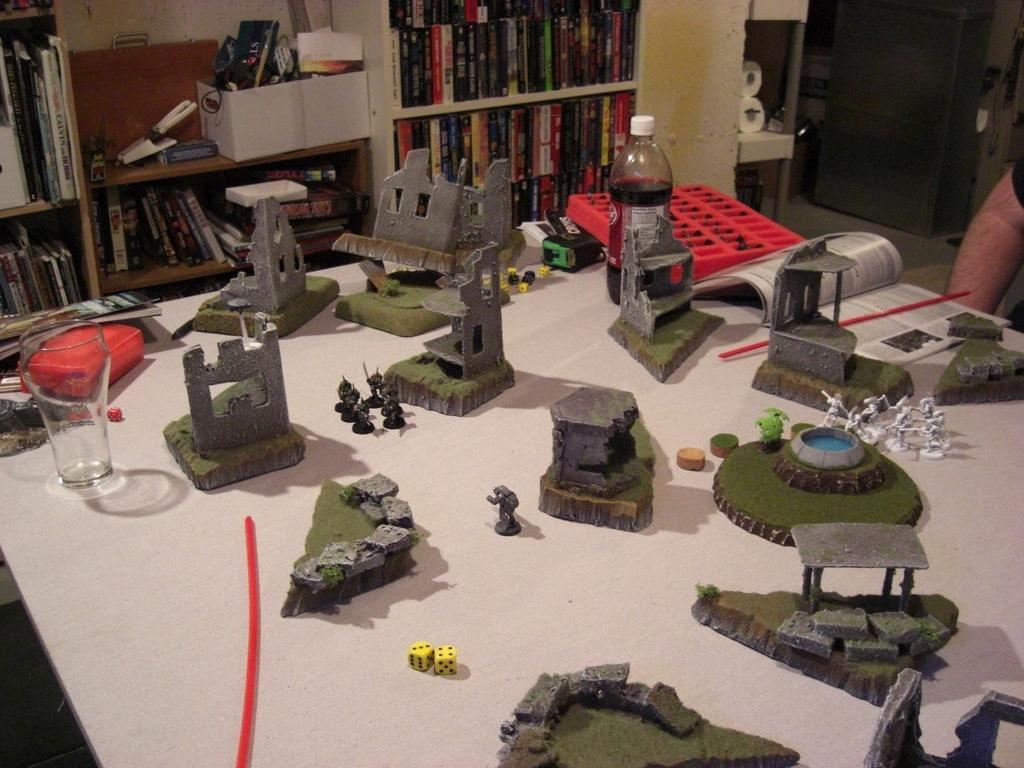Describe this image in one or two sentences. In this picture we can see some military toys, placed on the wooden table. Behind we can see a rack full of books. 